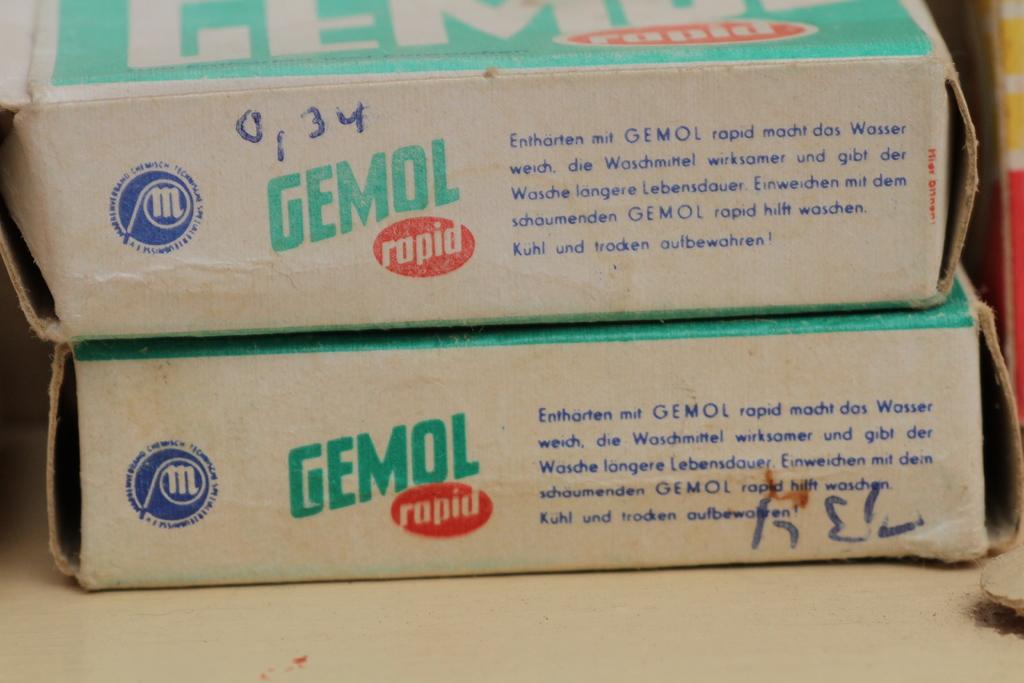What brand is written in green letters?
Ensure brevity in your answer.  Gemol. 